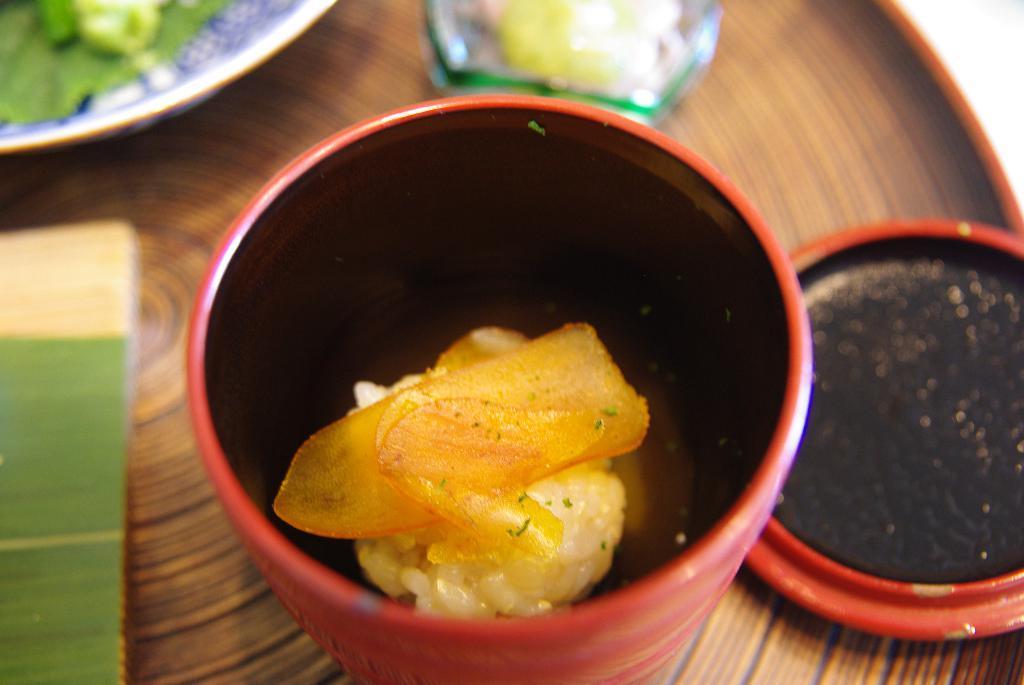Can you describe this image briefly? In this image there are some bowls on the table served with food, beside them there are so many other things. 